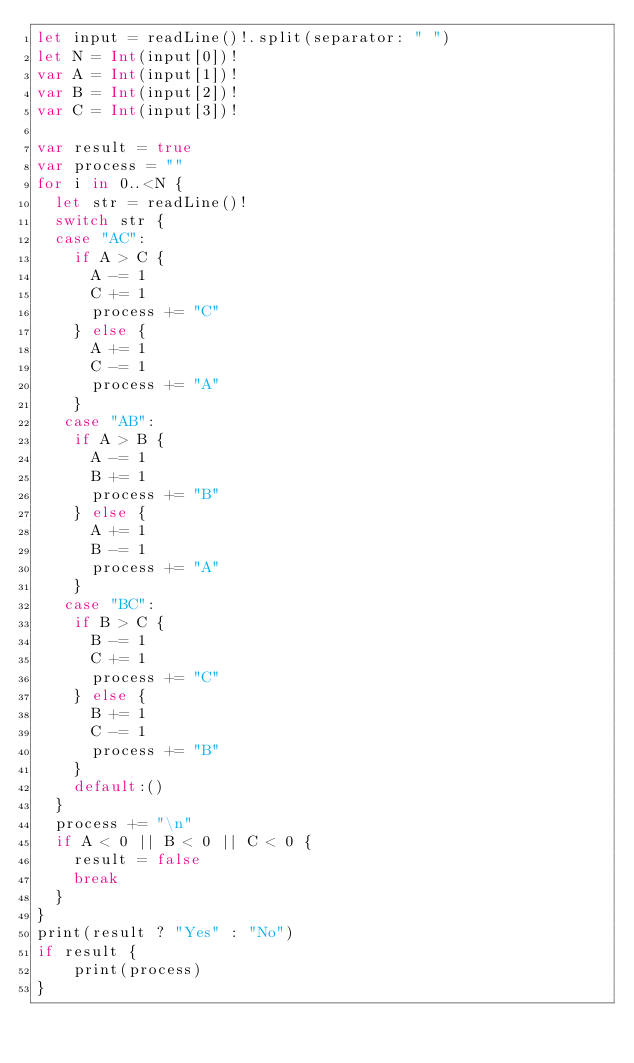Convert code to text. <code><loc_0><loc_0><loc_500><loc_500><_Swift_>let input = readLine()!.split(separator: " ")
let N = Int(input[0])!
var A = Int(input[1])!
var B = Int(input[2])!
var C = Int(input[3])!

var result = true
var process = ""
for i in 0..<N {
  let str = readLine()!
  switch str {
  case "AC":
  	if A > C {
      A -= 1
      C += 1
      process += "C"
    } else {
      A += 1
      C -= 1
      process += "A"
    }
   case "AB":
    if A > B {
      A -= 1
      B += 1
      process += "B"
    } else {
      A += 1
      B -= 1
      process += "A"
    }
   case "BC":
    if B > C {
      B -= 1
      C += 1
      process += "C"
    } else {
      B += 1
      C -= 1
      process += "B"
    }
    default:()
  }
  process += "\n"
  if A < 0 || B < 0 || C < 0 {
    result = false
    break
  }
}
print(result ? "Yes" : "No")
if result {
	print(process)
}</code> 